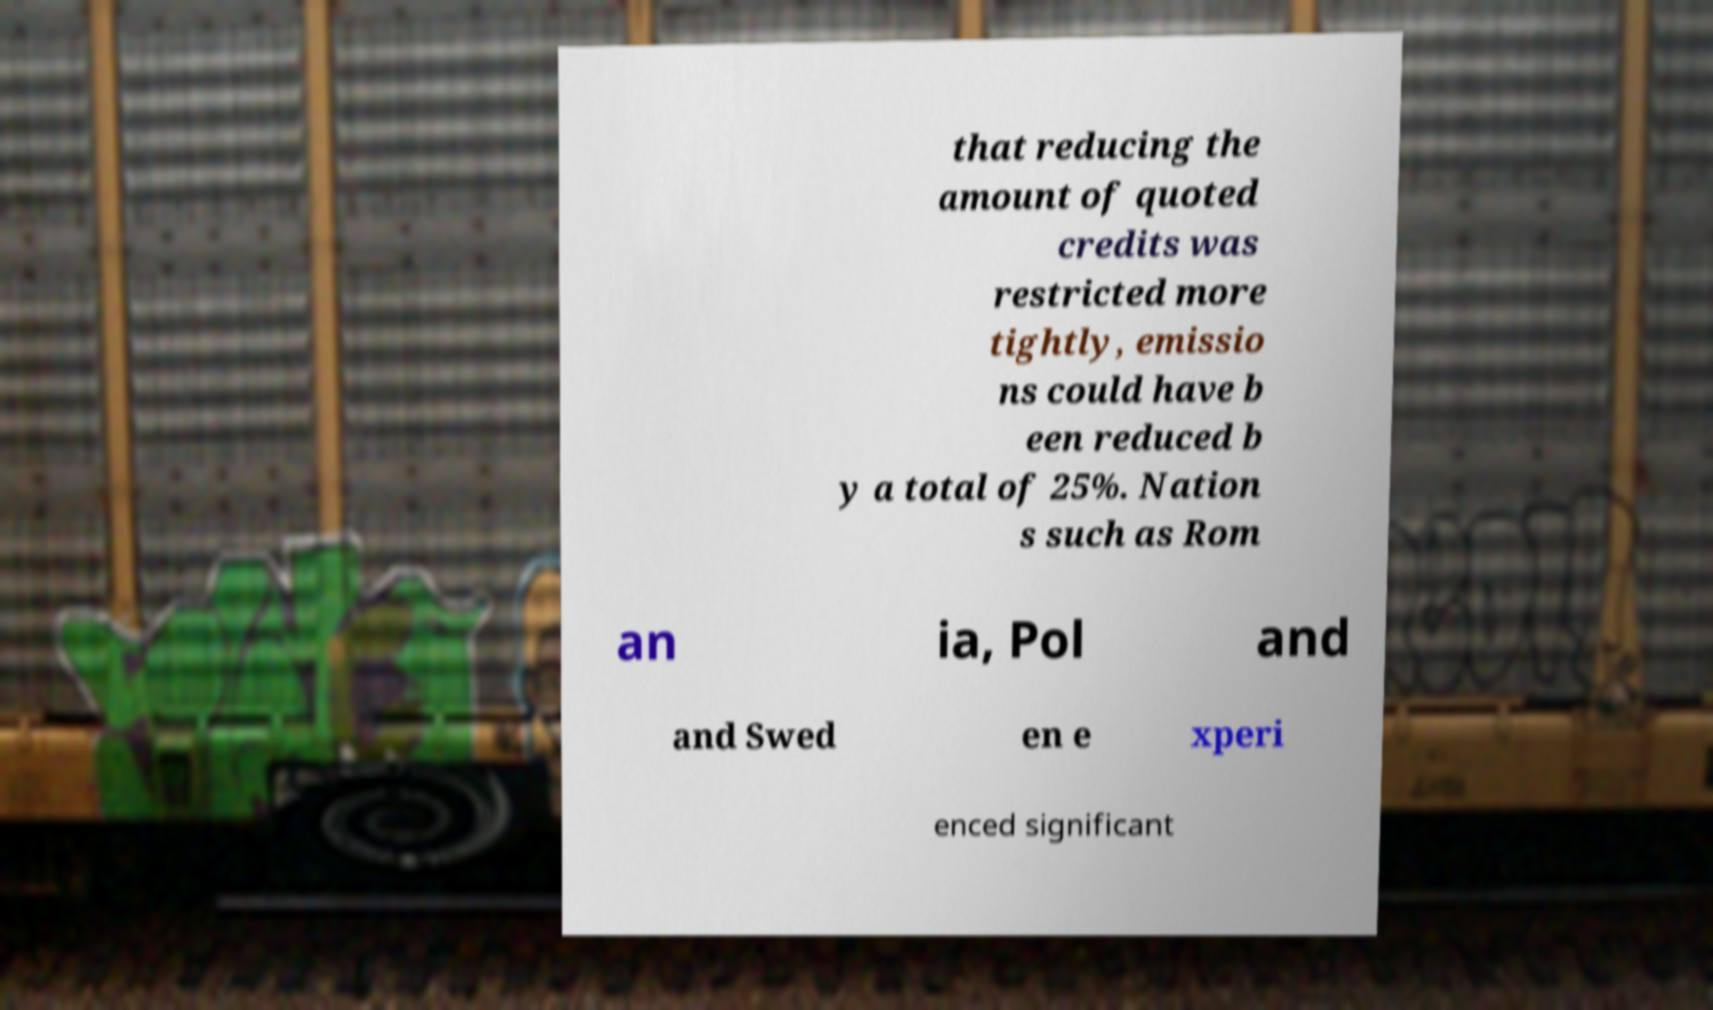Could you extract and type out the text from this image? that reducing the amount of quoted credits was restricted more tightly, emissio ns could have b een reduced b y a total of 25%. Nation s such as Rom an ia, Pol and and Swed en e xperi enced significant 